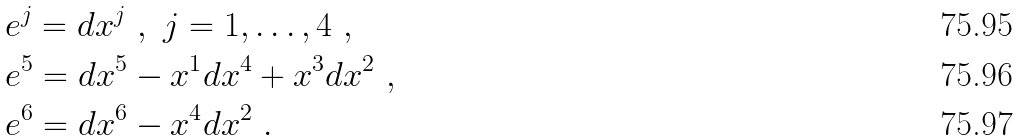<formula> <loc_0><loc_0><loc_500><loc_500>& e ^ { j } = d x ^ { j } \ , \ j = 1 , \dots , 4 \ , \\ & e ^ { 5 } = d x ^ { 5 } - x ^ { 1 } d x ^ { 4 } + x ^ { 3 } d x ^ { 2 } \ , \\ & e ^ { 6 } = d x ^ { 6 } - x ^ { 4 } d x ^ { 2 } \ .</formula> 